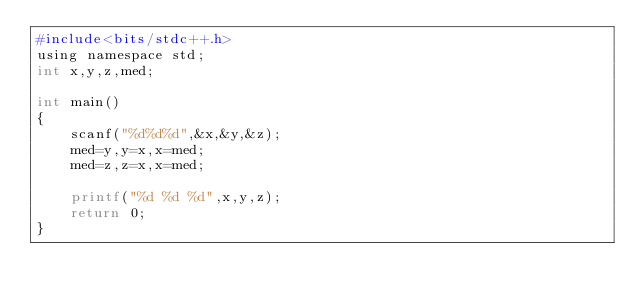<code> <loc_0><loc_0><loc_500><loc_500><_Awk_>#include<bits/stdc++.h>
using namespace std;
int x,y,z,med;

int main()
{
	scanf("%d%d%d",&x,&y,&z);
	med=y,y=x,x=med;
	med=z,z=x,x=med;
	
	printf("%d %d %d",x,y,z);
	return 0;
}</code> 